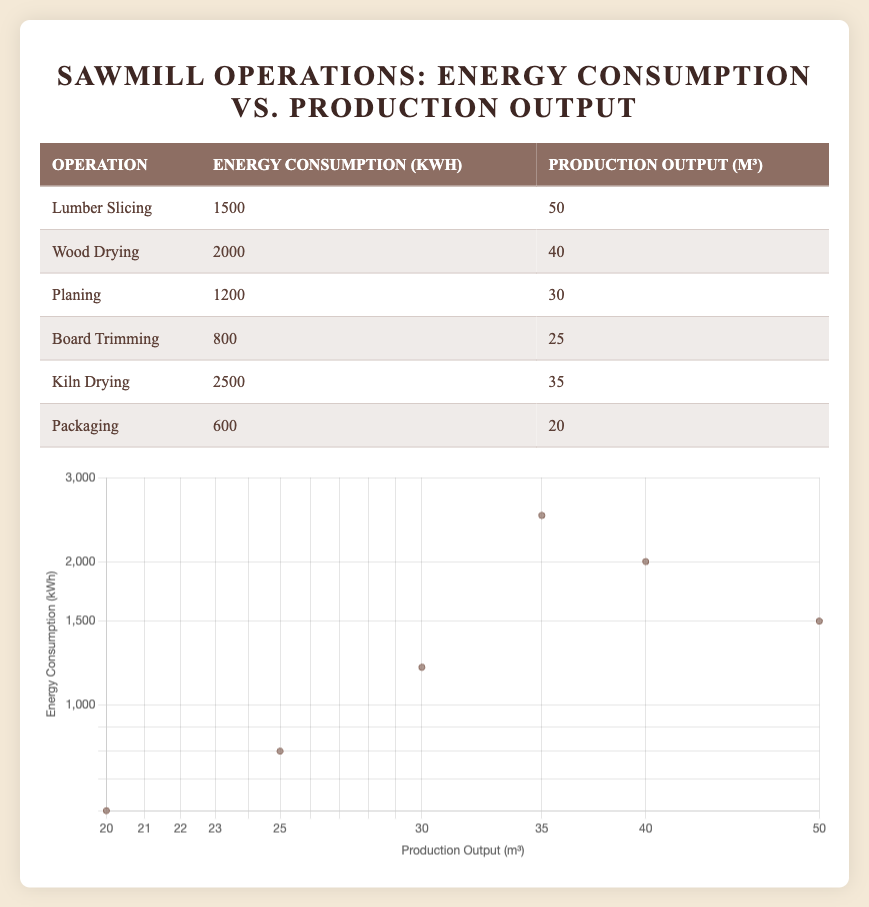What is the energy consumption for Board Trimming? The table lists the energy consumption of each operation. Looking for Board Trimming, I see that the energy consumption is listed as 800 kWh.
Answer: 800 kWh Which operation has the highest production output? By comparing the production output values in the table, Lumber Slicing has the highest production output at 50 m³.
Answer: Lumber Slicing What is the average energy consumption of all operations? To find the average, I first sum the energy consumption values: 1500 + 2000 + 1200 + 800 + 2500 + 600 = 10500 kWh. Then, I divide by the number of operations (6): 10500 / 6 = 1750 kWh.
Answer: 1750 kWh Does Kiln Drying consume more energy than Wood Drying? Comparing the energy consumption values, Kiln Drying consumes 2500 kWh, while Wood Drying consumes 2000 kWh. Since 2500 is greater than 2000, the statement is true.
Answer: Yes What is the difference in production output between Packaging and Planing? The production output for Packaging is 20 m³, and for Planing, it is 30 m³. The difference is 30 - 20 = 10 m³.
Answer: 10 m³ What operation has the least energy consumption? Reviewing the table, Packaging has the lowest energy consumption at 600 kWh, which is less than all other operations listed.
Answer: Packaging Is the production output for Wood Drying greater than that for Kiln Drying? The production output for Wood Drying is 40 m³, while for Kiln Drying it is 35 m³. Since 40 is greater than 35, this statement is true.
Answer: Yes If we combine the energy consumptions of Lumber Slicing and Planing, what is the total? Lumber Slicing consumes 1500 kWh and Planing consumes 1200 kWh. Adding these gives 1500 + 1200 = 2700 kWh.
Answer: 2700 kWh Which operations have an energy consumption of less than 1500 kWh? From the table, we check each value: Board Trimming (800 kWh), Packaging (600 kWh) fit this criterion, indicating there are two operations below 1500 kWh.
Answer: 2 operations (Board Trimming and Packaging) 